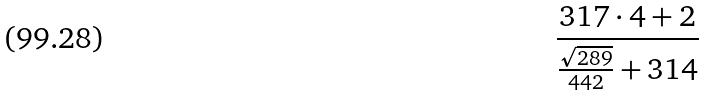<formula> <loc_0><loc_0><loc_500><loc_500>\frac { 3 1 7 \cdot 4 + 2 } { \frac { \sqrt { 2 8 9 } } { 4 4 2 } + 3 1 4 }</formula> 